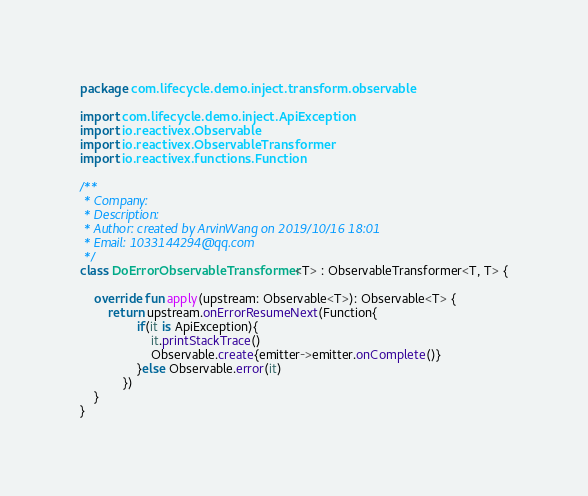<code> <loc_0><loc_0><loc_500><loc_500><_Kotlin_>package com.lifecycle.demo.inject.transform.observable

import com.lifecycle.demo.inject.ApiException
import io.reactivex.Observable
import io.reactivex.ObservableTransformer
import io.reactivex.functions.Function

/**
 * Company:
 * Description:
 * Author: created by ArvinWang on 2019/10/16 18:01
 * Email: 1033144294@qq.com
 */
class DoErrorObservableTransformer <T> : ObservableTransformer<T, T> {

    override fun apply(upstream: Observable<T>): Observable<T> {
        return upstream.onErrorResumeNext(Function{
                if(it is ApiException){
                    it.printStackTrace()
                    Observable.create{emitter->emitter.onComplete()}
                }else Observable.error(it)
            })
    }
}
</code> 